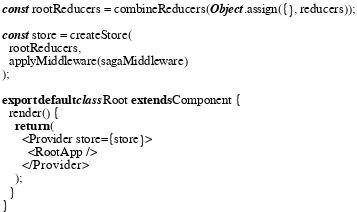<code> <loc_0><loc_0><loc_500><loc_500><_JavaScript_>
const rootReducers = combineReducers(Object.assign({}, reducers));

const store = createStore(
  rootReducers,
  applyMiddleware(sagaMiddleware)
);

export default class Root extends Component {
  render() {
    return (
      <Provider store={store}>
        <RootApp />
      </Provider>
    );
  }
}
</code> 